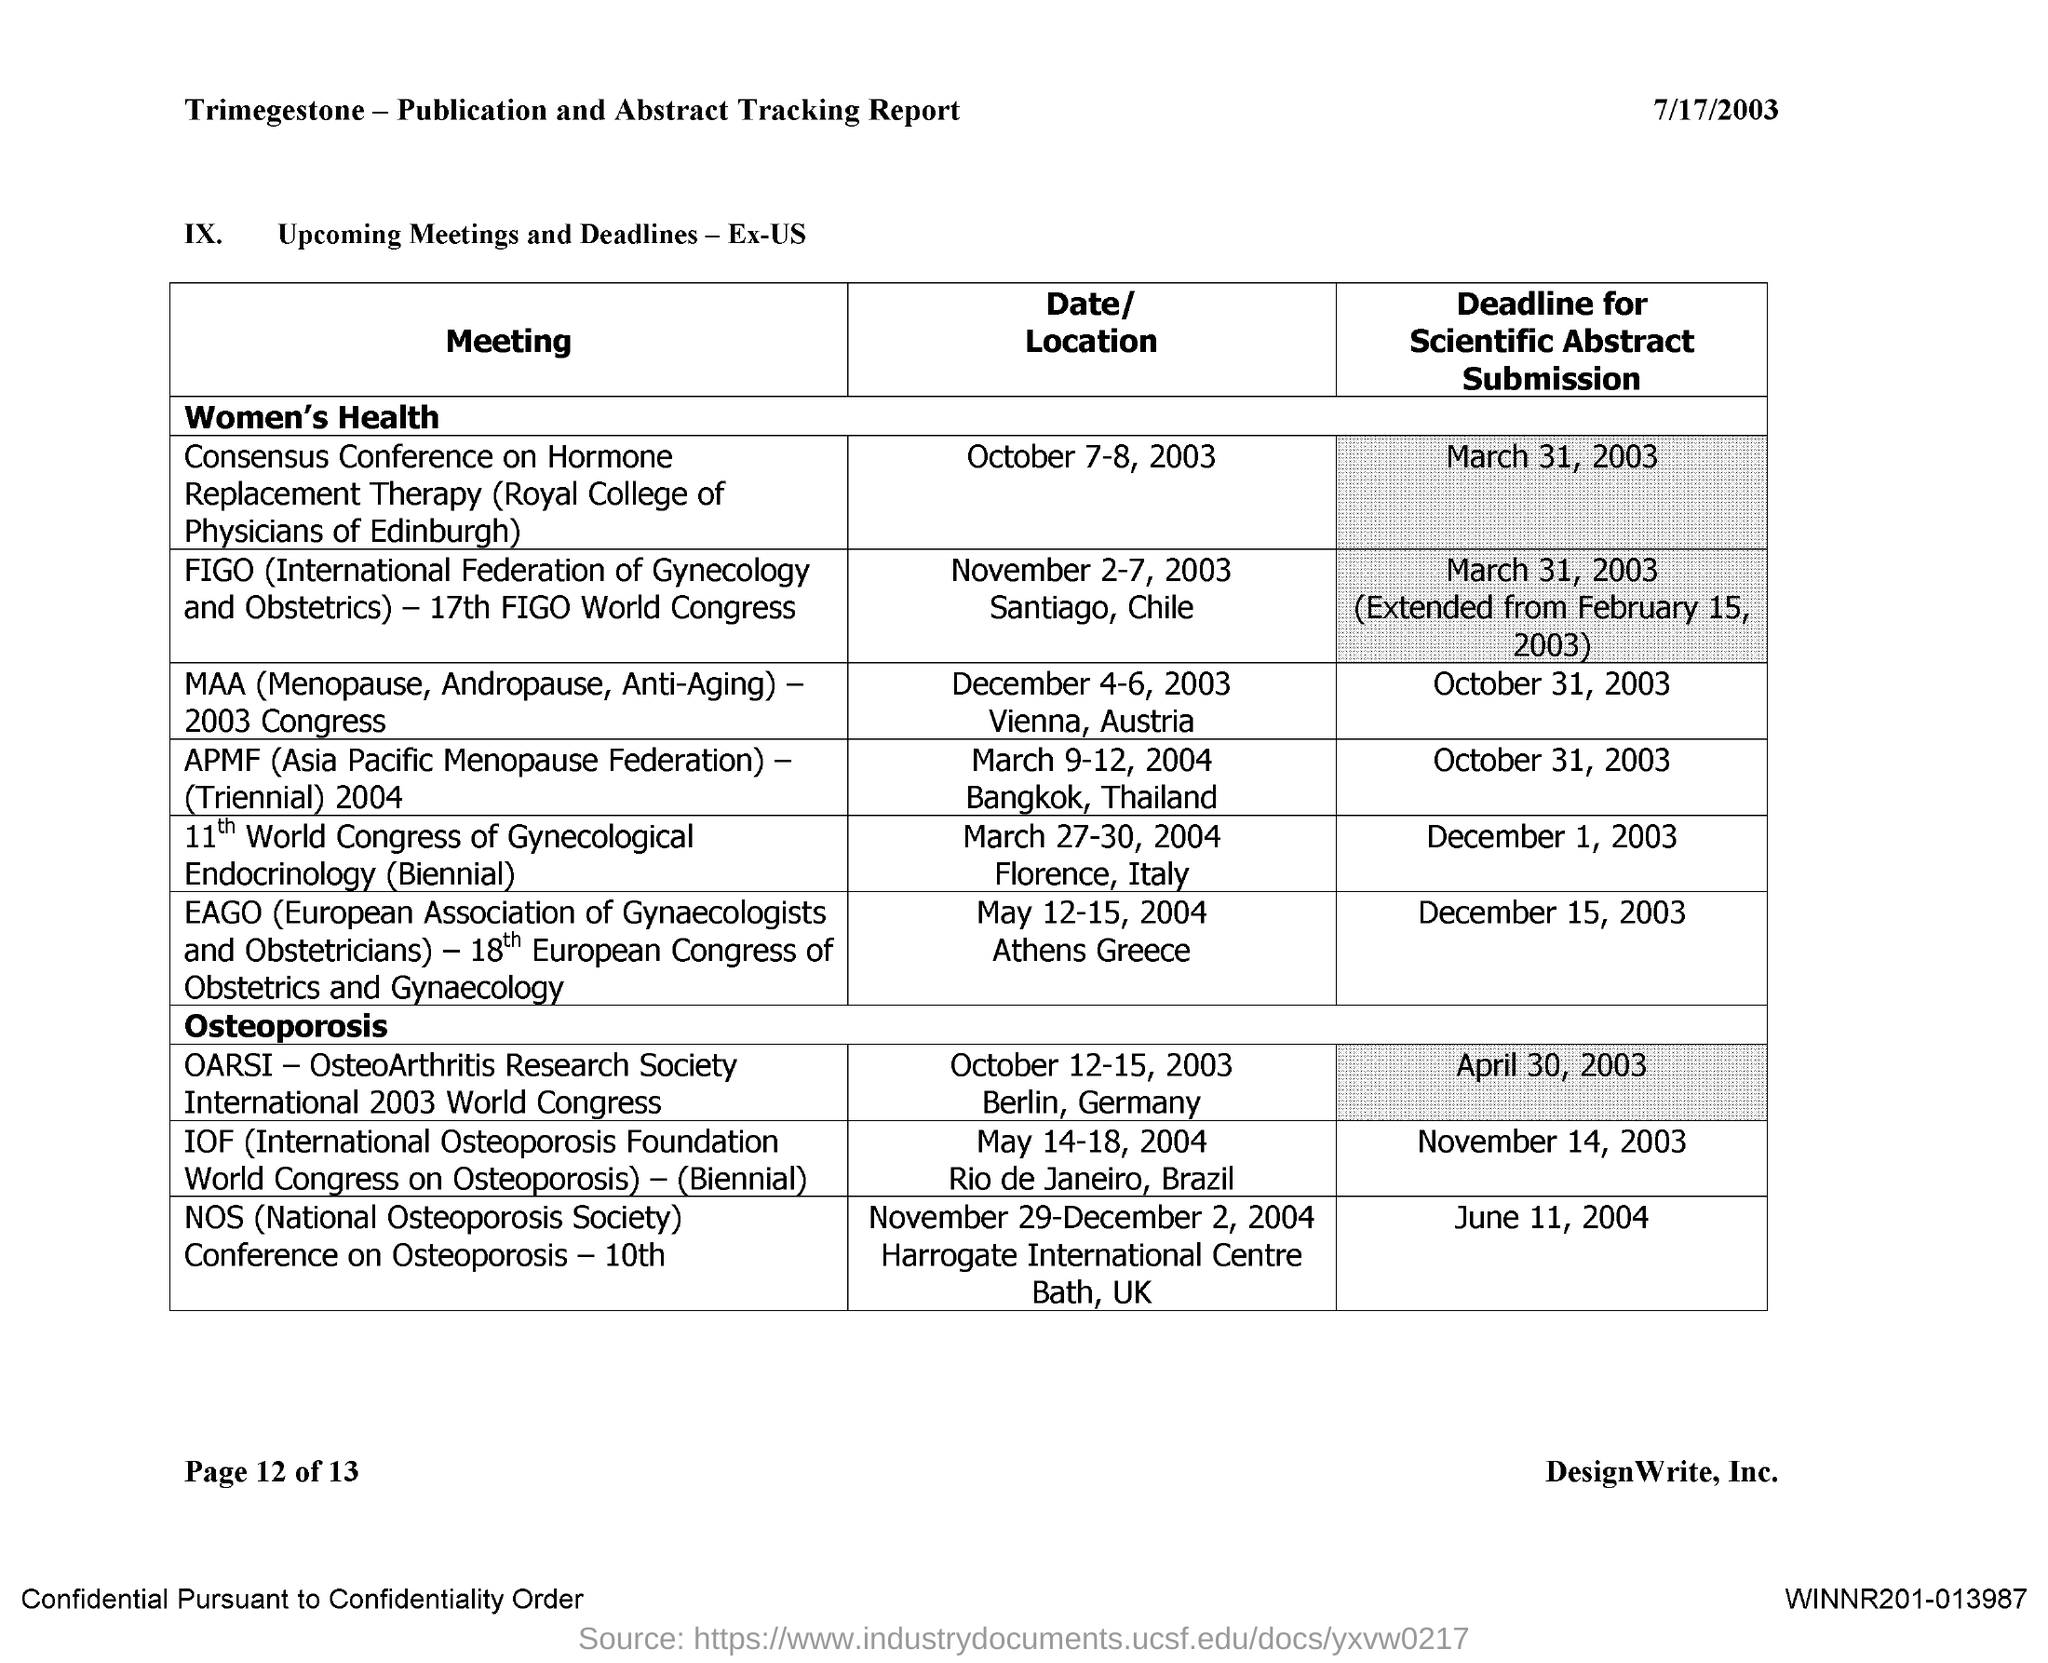Point out several critical features in this image. The date written on the top left of the page is July 17, 2003. 